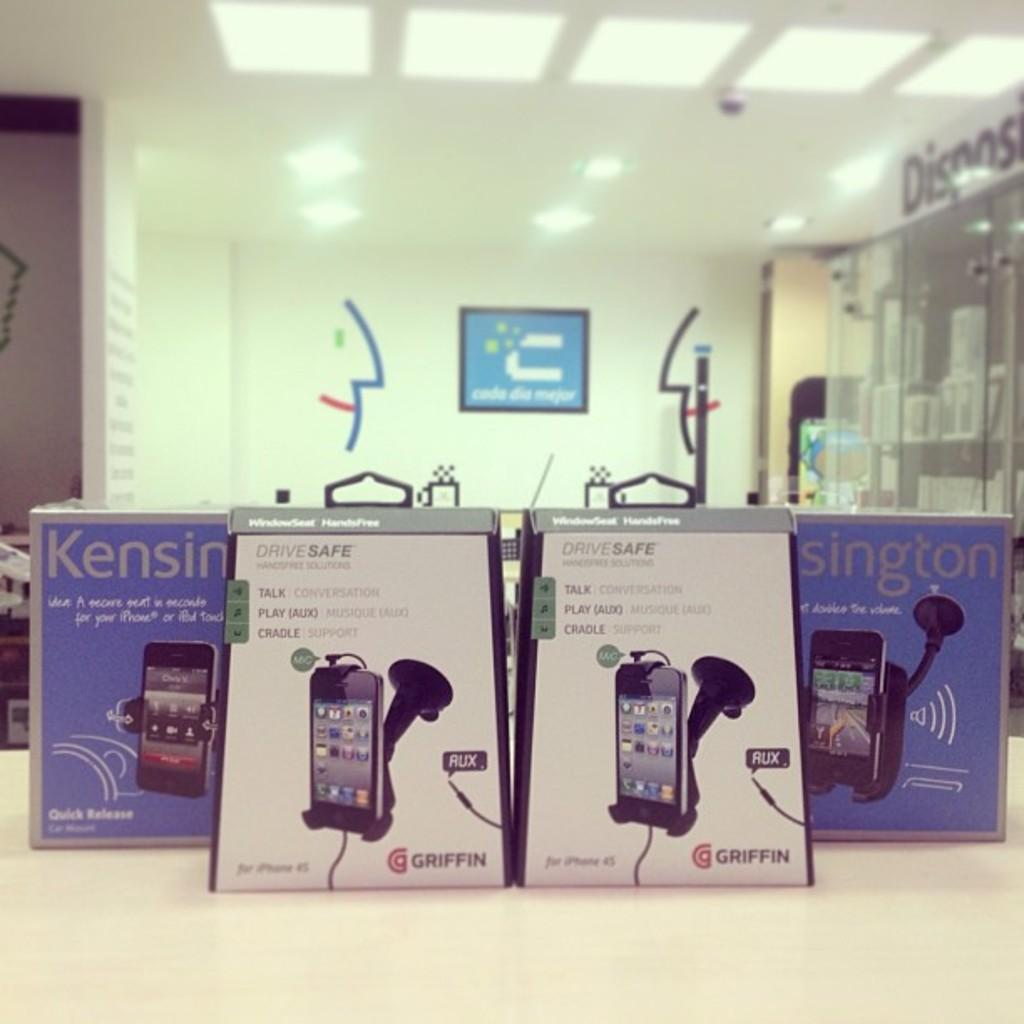<image>
Write a terse but informative summary of the picture. display for kensington hands free phone car product 